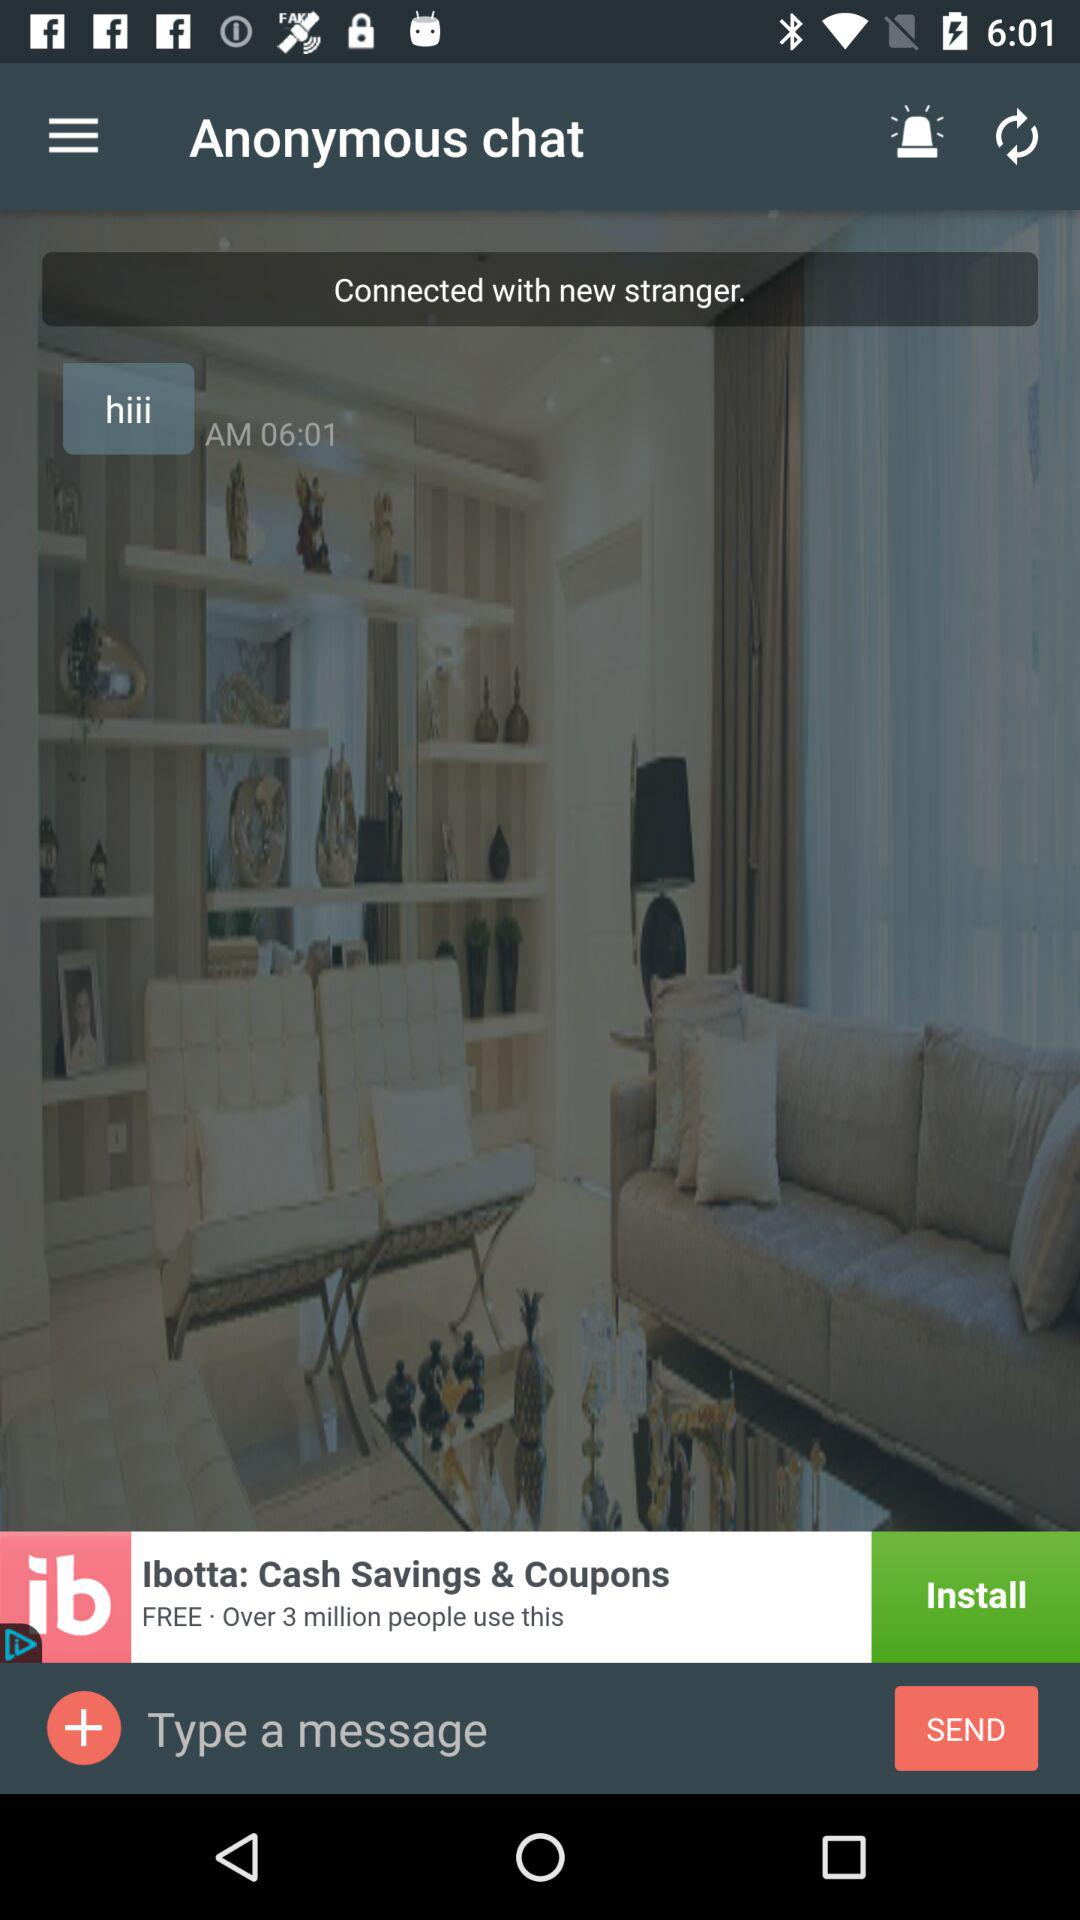What time did the "hiii" message come? The "hiii" message came at 6:01 a.m. 